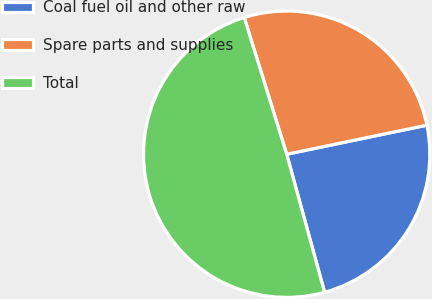Convert chart to OTSL. <chart><loc_0><loc_0><loc_500><loc_500><pie_chart><fcel>Coal fuel oil and other raw<fcel>Spare parts and supplies<fcel>Total<nl><fcel>23.99%<fcel>26.54%<fcel>49.47%<nl></chart> 